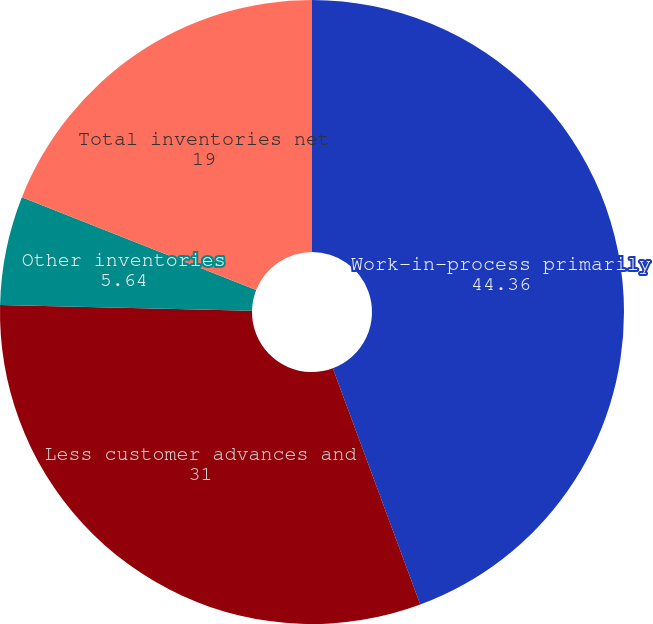Convert chart to OTSL. <chart><loc_0><loc_0><loc_500><loc_500><pie_chart><fcel>Work-in-process primarily<fcel>Less customer advances and<fcel>Other inventories<fcel>Total inventories net<nl><fcel>44.36%<fcel>31.0%<fcel>5.64%<fcel>19.0%<nl></chart> 